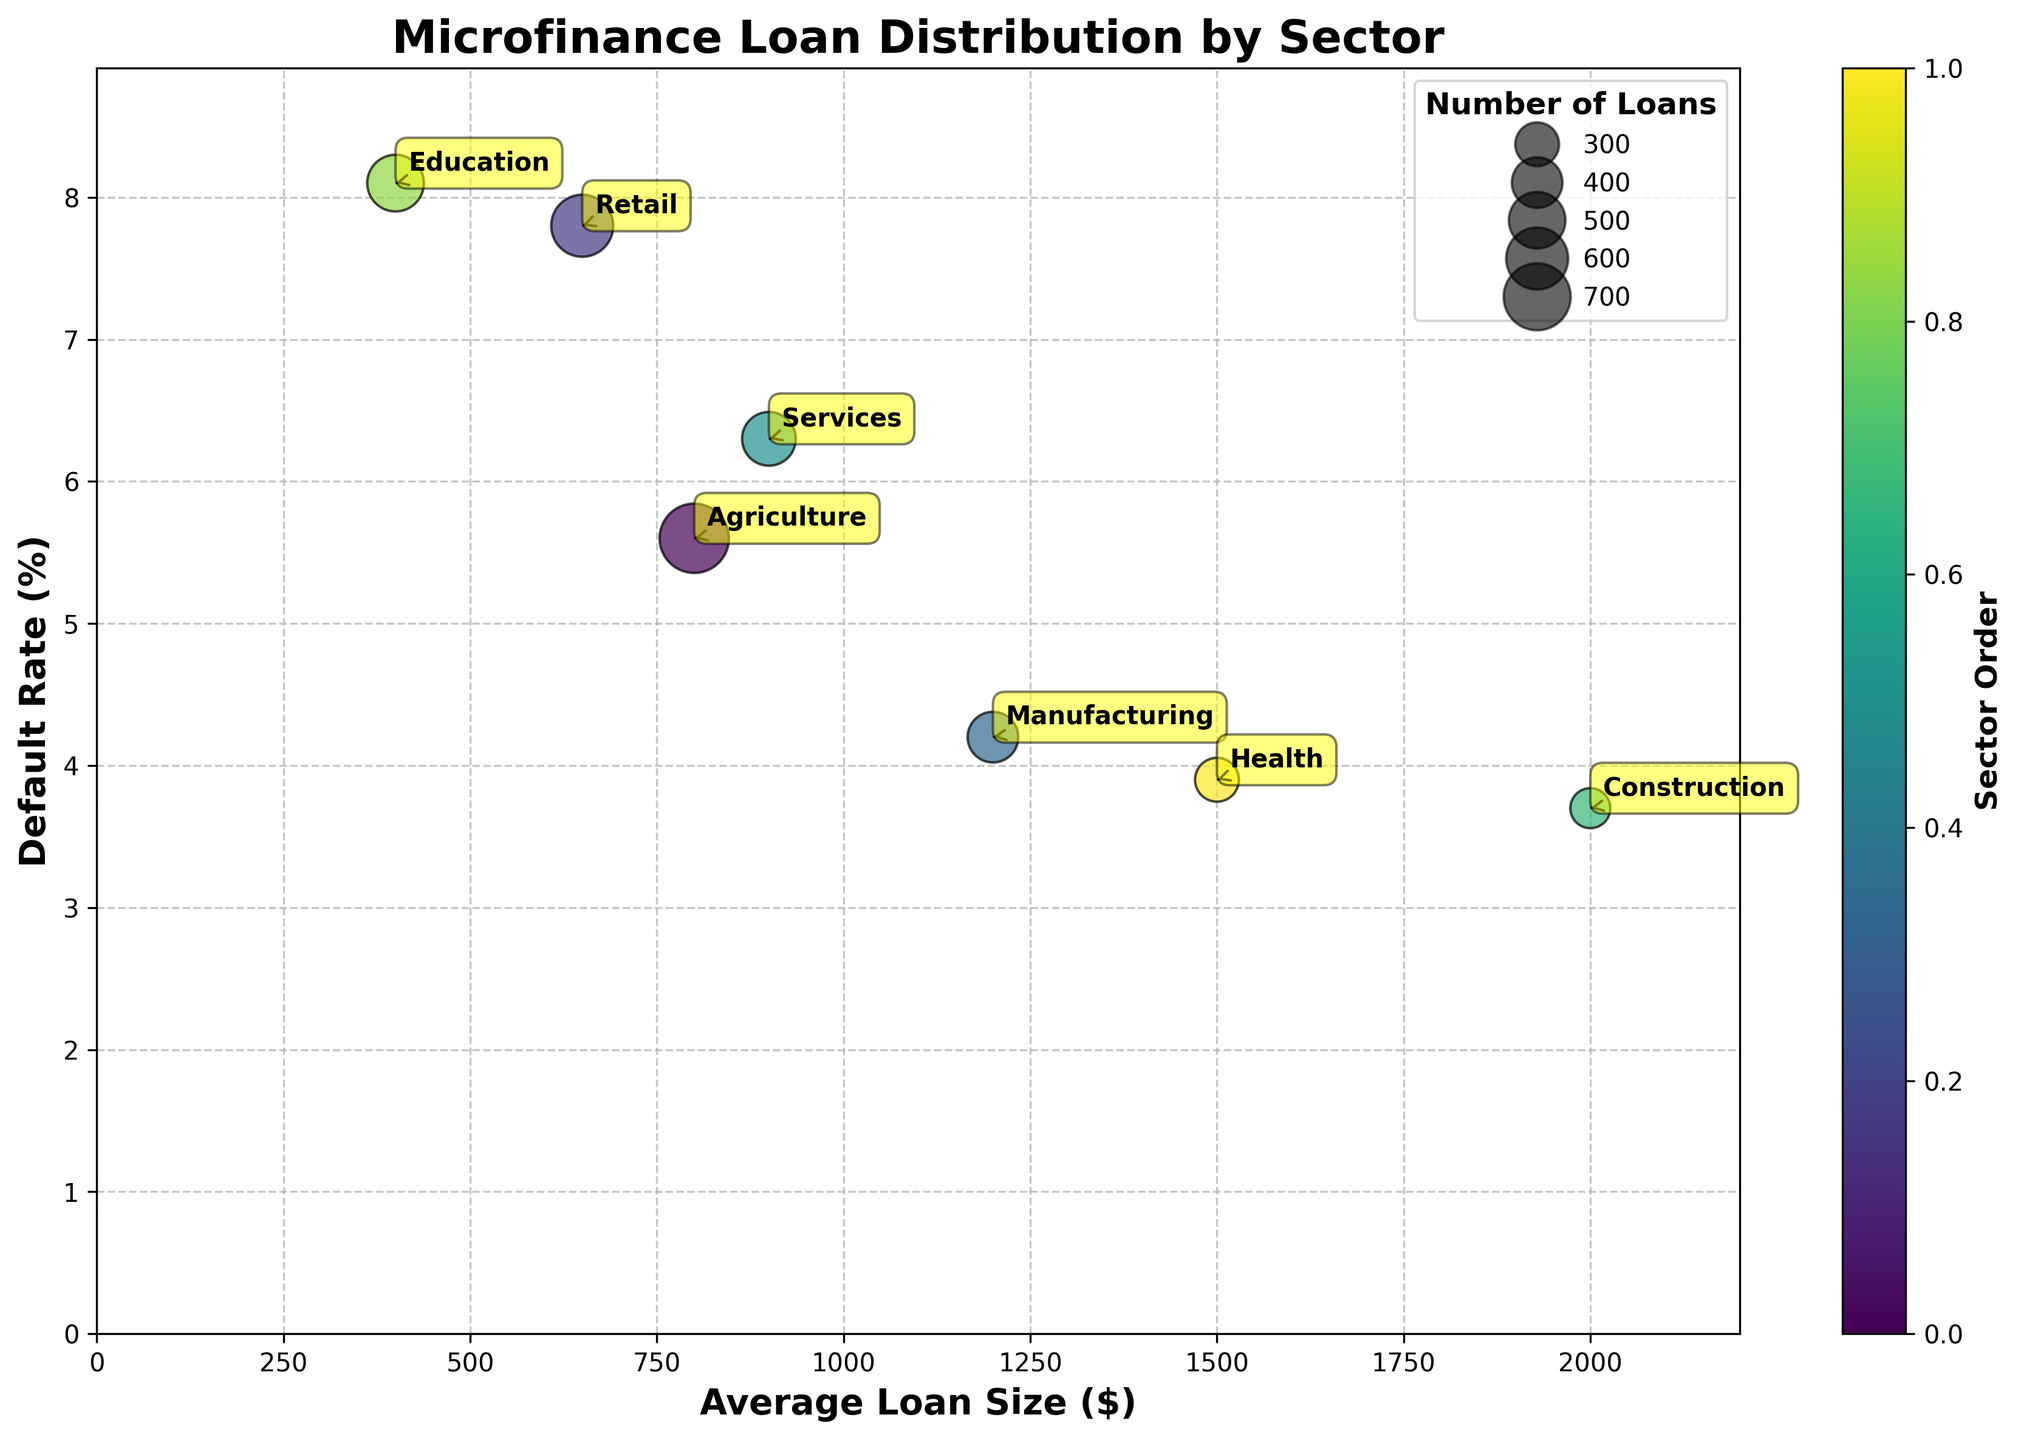What is the title of the figure? The title is usually found at the top of the figure. In this case, it reads "Microfinance Loan Distribution by Sector".
Answer: Microfinance Loan Distribution by Sector Which sector has the highest average loan size? The average loan size is represented on the x-axis. The sector positioned farthest to the right has the highest average loan size. In this case, it is "Construction" with $2000.
Answer: Construction What is the default rate for the retail sector? The default rate is represented on the y-axis, and the sectors are labeled next to their respective points. The point for "Retail" is at a default rate of 7.8%.
Answer: 7.8% How many loans are in the health sector? The size of the bubbles corresponds to the number of loans. For the health sector, the bubble size corresponds to 60 loans.
Answer: 60 Which sector has the smallest default rate? The sector with the smallest default rate is the one located lowest on the y-axis. In this case, it is "Construction" with 3.7%.
Answer: Construction Compare the loan sizes between the Agriculture and Manufacturing sectors. Which one is higher? Check the positions of these sectors along the x-axis. The higher value is farther to the right. "Manufacturing" is at $1200, while "Agriculture" is at $800. Hence, Manufacturing has a higher loan size.
Answer: Manufacturing Which sector has the highest default rate, and what is the percentage? The default rate is on the y-axis. The highest point corresponds to the highest default rate. "Education" has the highest default rate of 8.1%.
Answer: Education, 8.1% What is the average loan size across all sectors? Add up all average loan sizes and divide by the number of sectors. (800 + 650 + 1200 + 900 + 2000 + 400 + 1500) / 7 = 8450/7 = 1207.14.
Answer: 1207.14 Which two sectors have the closest average loan sizes, and what are those sizes? Find sectors with x-axis values that are closest together. "Agriculture" (800) and "Retail" (650) are closest, with a difference of 150.
Answer: Agriculture (800) and Retail (650) How does the number of loans in the education sector compare to the retail sector? Compare the sizes of the respective bubbles. Education has 100 loans, and Retail has 120 loans. Retail has more loans.
Answer: Retail has more loans 